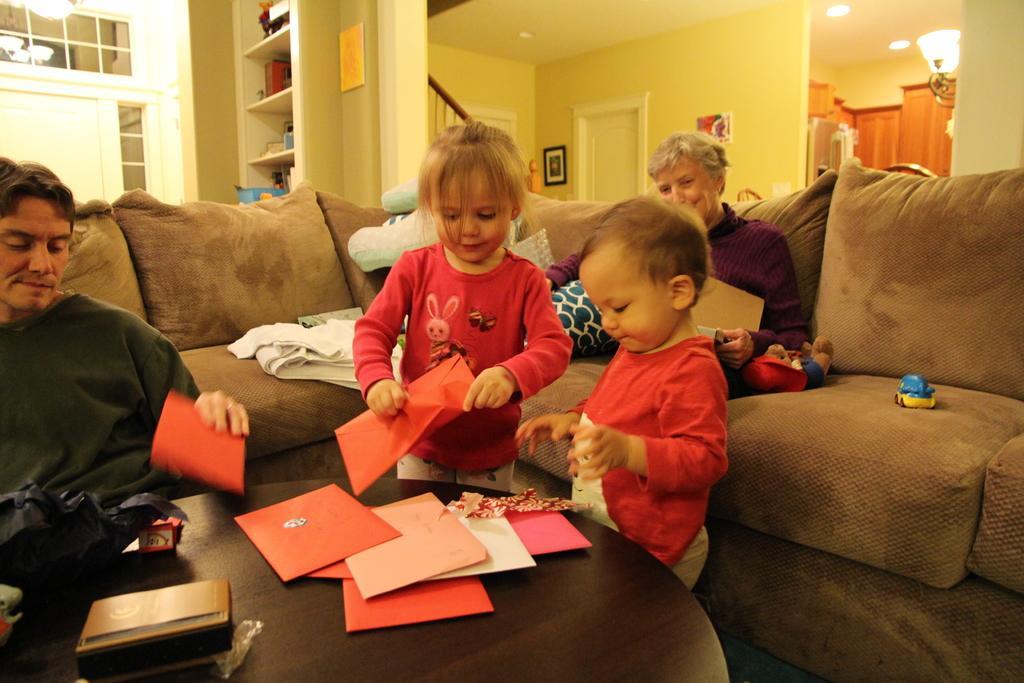Please provide a concise description of this image. In the image we can see there are two kids standing and they are holding envelopes in their hand. There are people sitting on the sofa and there are toys on the sofa. Behind there is a wall which is in yellow colour. 